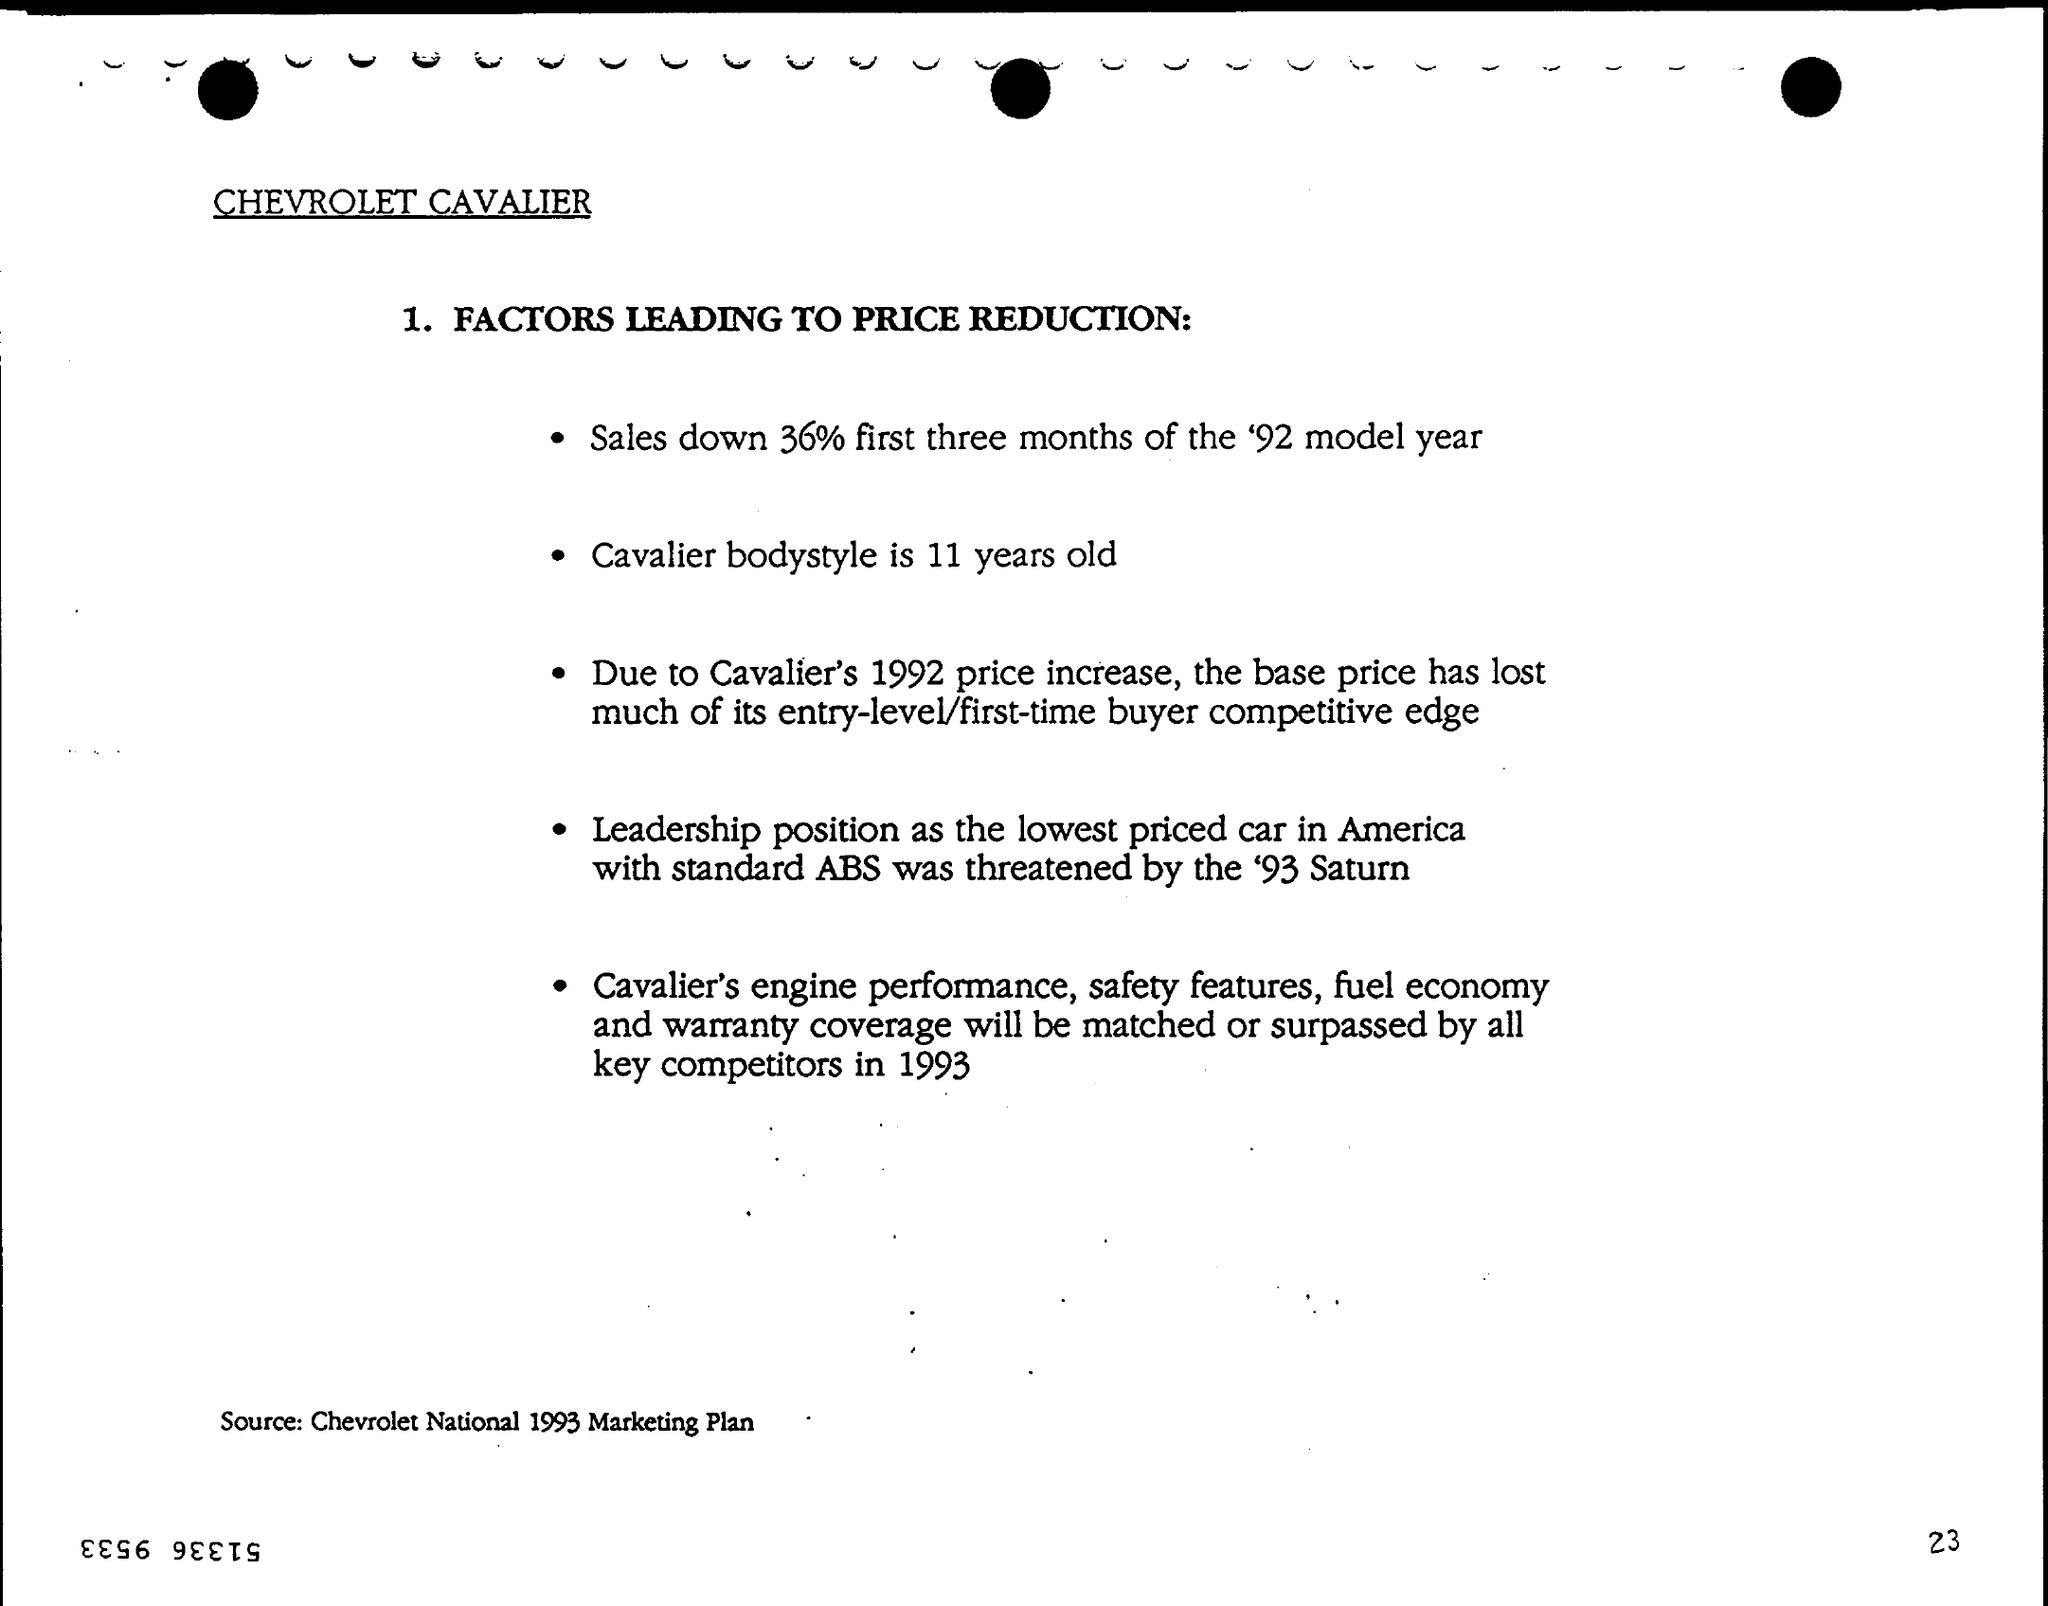Which brand is mentioned?
Ensure brevity in your answer.  Chevrolet Cavalier. How much did sales go down first three months?
Your answer should be very brief. 36%. How old is the Cavalier bodystyle?
Your answer should be very brief. 11 years. What is the source mentioned at the bottom of the page?
Provide a short and direct response. Chevrolet National 1993 Marketing Plan. 